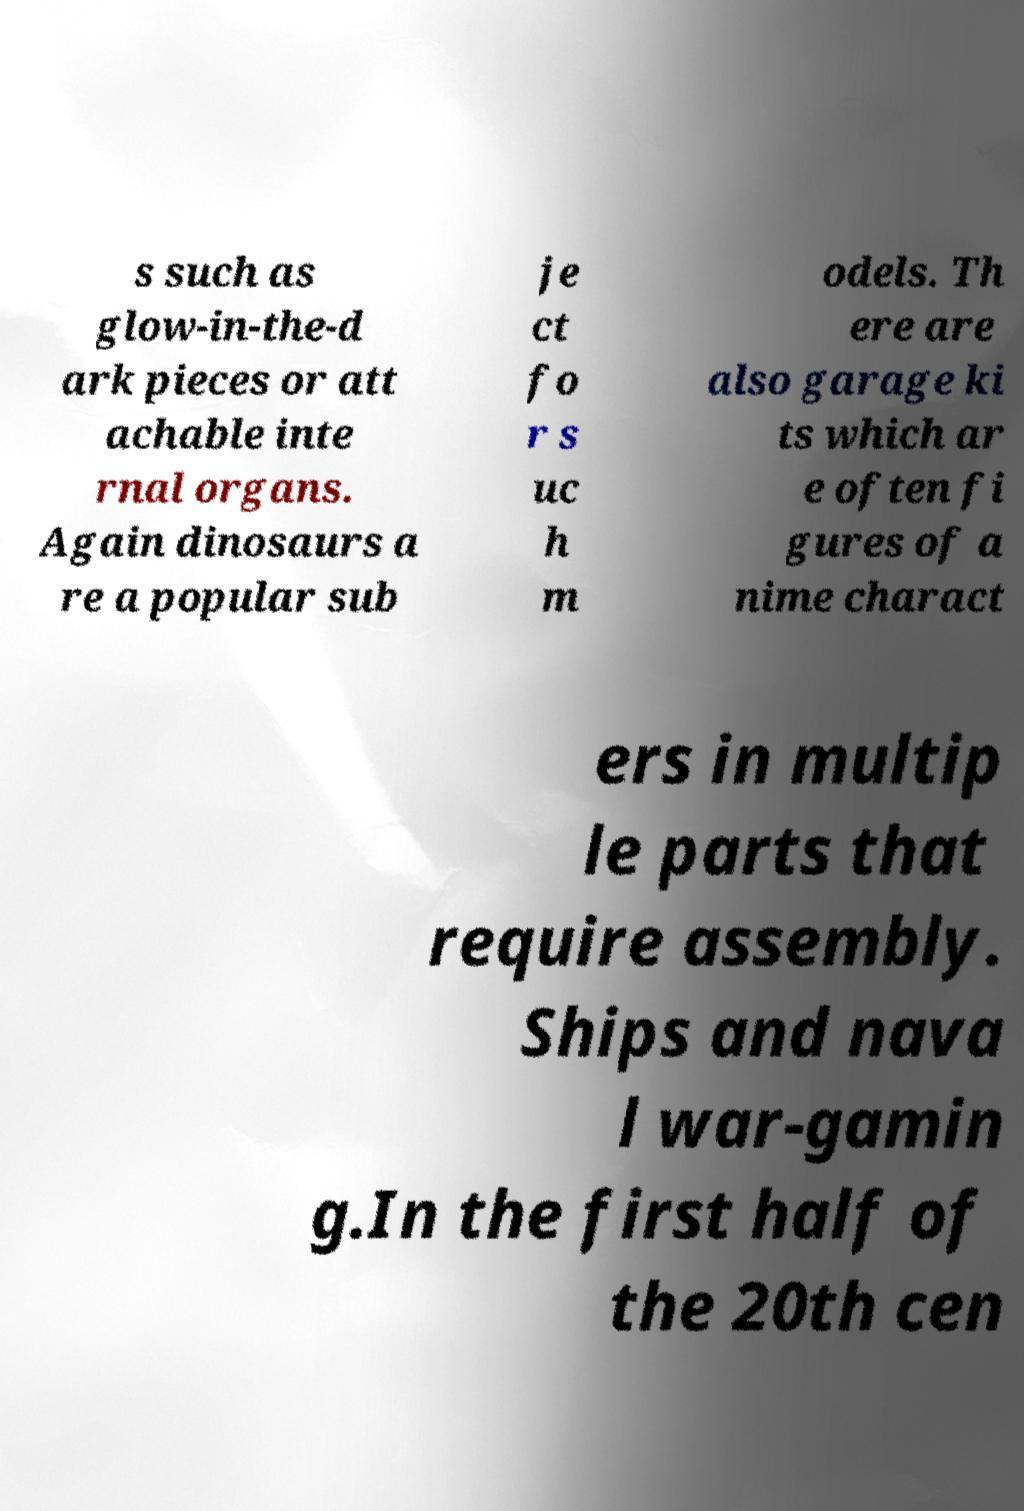Could you extract and type out the text from this image? s such as glow-in-the-d ark pieces or att achable inte rnal organs. Again dinosaurs a re a popular sub je ct fo r s uc h m odels. Th ere are also garage ki ts which ar e often fi gures of a nime charact ers in multip le parts that require assembly. Ships and nava l war-gamin g.In the first half of the 20th cen 